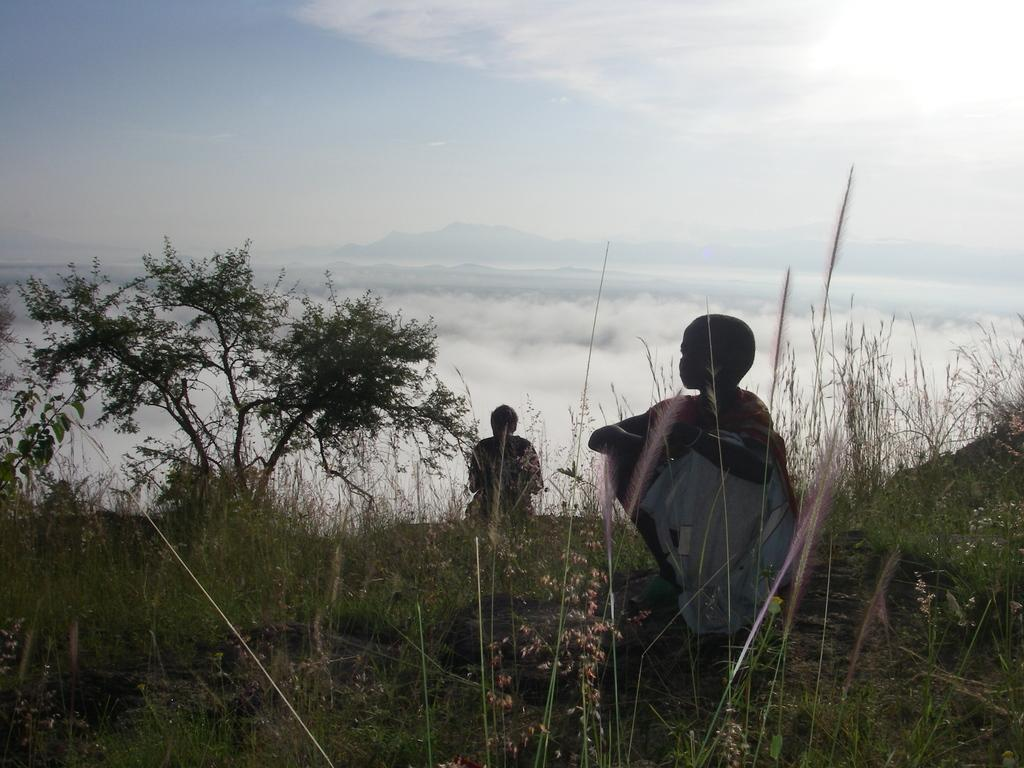How many people are in the image? There are two members in the image. Where are the members located? The members are on the land. What type of vegetation is present on the ground? There is grass on the ground. What can be seen on the left side of the image? There is a tree on the left side of the image. What is visible in the background of the image? There are clouds in the sky in the background. What type of form does the knee of the person on the right have in the image? There is no indication of a person's knee in the image, as the focus is on the two members and their surroundings. 